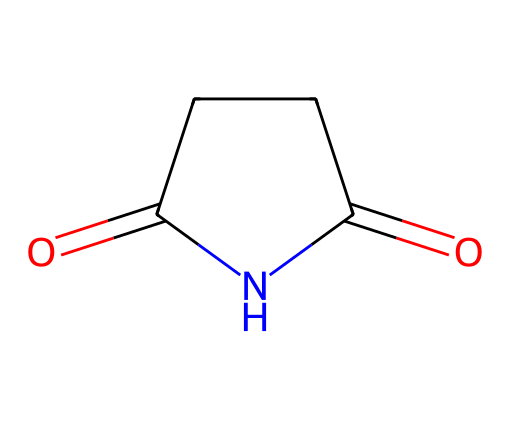What is the chemical name represented by the SMILES? The SMILES representation indicates a structure containing a cyclic imide, specifically a five-membered ring with a carbonyl and nitrogen atom, which corresponds to succinimide.
Answer: succinimide How many carbon atoms are present in this molecule? By analyzing the SMILES, we can count the carbon atoms in the cyclic structure: there are four carbon atoms forming part of the five-membered ring structure.
Answer: 4 What type of linkage is present between the nitrogen and the carbon atoms? The structure shows that the nitrogen atom is connected to carbon atoms through single covalent bonds, as indicated by the absence of any double bond notation in that part of the SMILES.
Answer: single bonds How many oxygen atoms are present in the structure? Looking at the SMILES, there are two carbonyl (C=O) groups, indicating the presence of two oxygen atoms in the molecule.
Answer: 2 What functional groups are present in succinimide? The structure shows two carbonyl (C=O) groups and an imide functional group, as it is a cyclic compound with a nitrogen atom in the ring coupled with carbonyls.
Answer: carbonyl and imide Is succinimide considered an effective preservative in cosmetics? Succinimide has antimicrobial properties that can help preserve formulations, making it a potential candidate as a preservative due to its structure and functional groups.
Answer: Yes 